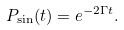<formula> <loc_0><loc_0><loc_500><loc_500>P _ { \sin } ( t ) = e ^ { - 2 \Gamma t } .</formula> 